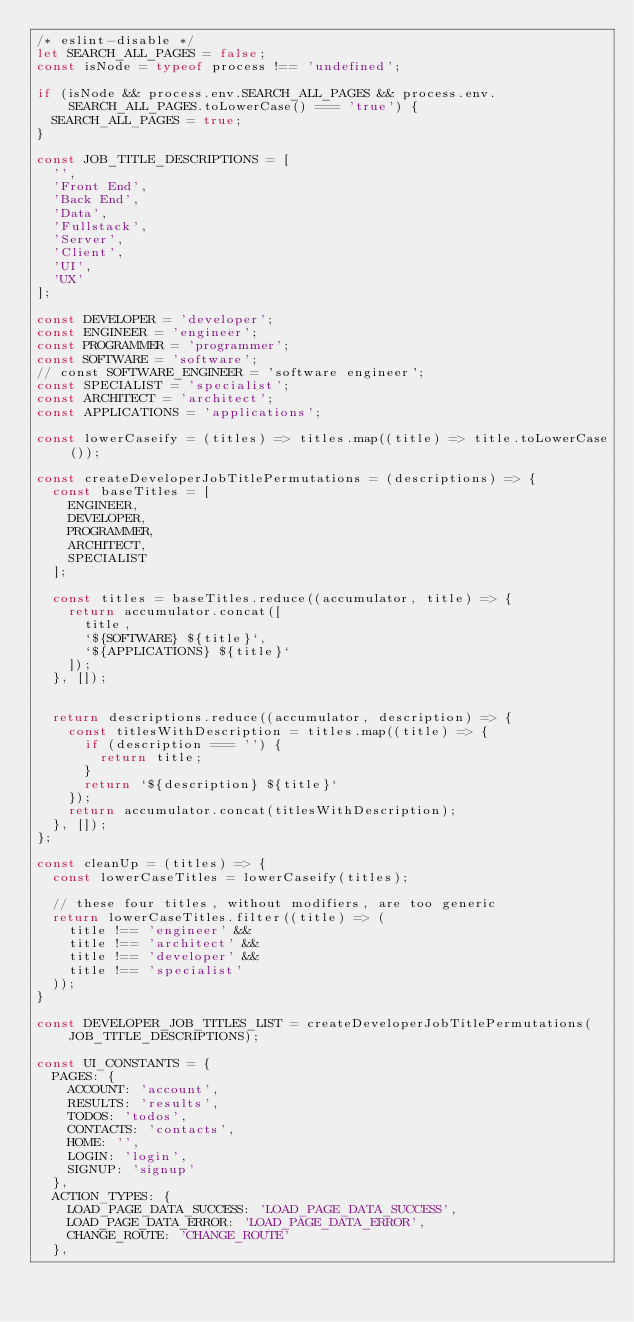Convert code to text. <code><loc_0><loc_0><loc_500><loc_500><_JavaScript_>/* eslint-disable */
let SEARCH_ALL_PAGES = false;
const isNode = typeof process !== 'undefined';

if (isNode && process.env.SEARCH_ALL_PAGES && process.env.SEARCH_ALL_PAGES.toLowerCase() === 'true') {
  SEARCH_ALL_PAGES = true;
}

const JOB_TITLE_DESCRIPTIONS = [
  '',
  'Front End',
  'Back End',
  'Data',
  'Fullstack',
  'Server',
  'Client',
  'UI',
  'UX'
];

const DEVELOPER = 'developer';
const ENGINEER = 'engineer';
const PROGRAMMER = 'programmer';
const SOFTWARE = 'software';
// const SOFTWARE_ENGINEER = 'software engineer';
const SPECIALIST = 'specialist';
const ARCHITECT = 'architect';
const APPLICATIONS = 'applications';

const lowerCaseify = (titles) => titles.map((title) => title.toLowerCase());

const createDeveloperJobTitlePermutations = (descriptions) => {
  const baseTitles = [
    ENGINEER,
    DEVELOPER,
    PROGRAMMER,
    ARCHITECT,
    SPECIALIST
  ];

  const titles = baseTitles.reduce((accumulator, title) => {
    return accumulator.concat([
      title,
      `${SOFTWARE} ${title}`,
      `${APPLICATIONS} ${title}`
    ]);
  }, []);


  return descriptions.reduce((accumulator, description) => {
    const titlesWithDescription = titles.map((title) => {
      if (description === '') {
        return title;
      }
      return `${description} ${title}`
    });
    return accumulator.concat(titlesWithDescription);
  }, []);
};

const cleanUp = (titles) => {
  const lowerCaseTitles = lowerCaseify(titles);

  // these four titles, without modifiers, are too generic
  return lowerCaseTitles.filter((title) => (
    title !== 'engineer' &&
    title !== 'architect' &&
    title !== 'developer' &&
    title !== 'specialist'
  ));
}

const DEVELOPER_JOB_TITLES_LIST = createDeveloperJobTitlePermutations(JOB_TITLE_DESCRIPTIONS);

const UI_CONSTANTS = {
  PAGES: {
    ACCOUNT: 'account',
    RESULTS: 'results',
    TODOS: 'todos',
    CONTACTS: 'contacts',
    HOME: '',
    LOGIN: 'login',
    SIGNUP: 'signup'
  },
  ACTION_TYPES: {
    LOAD_PAGE_DATA_SUCCESS: 'LOAD_PAGE_DATA_SUCCESS',
    LOAD_PAGE_DATA_ERROR: 'LOAD_PAGE_DATA_ERROR',
    CHANGE_ROUTE: 'CHANGE_ROUTE'
  },</code> 